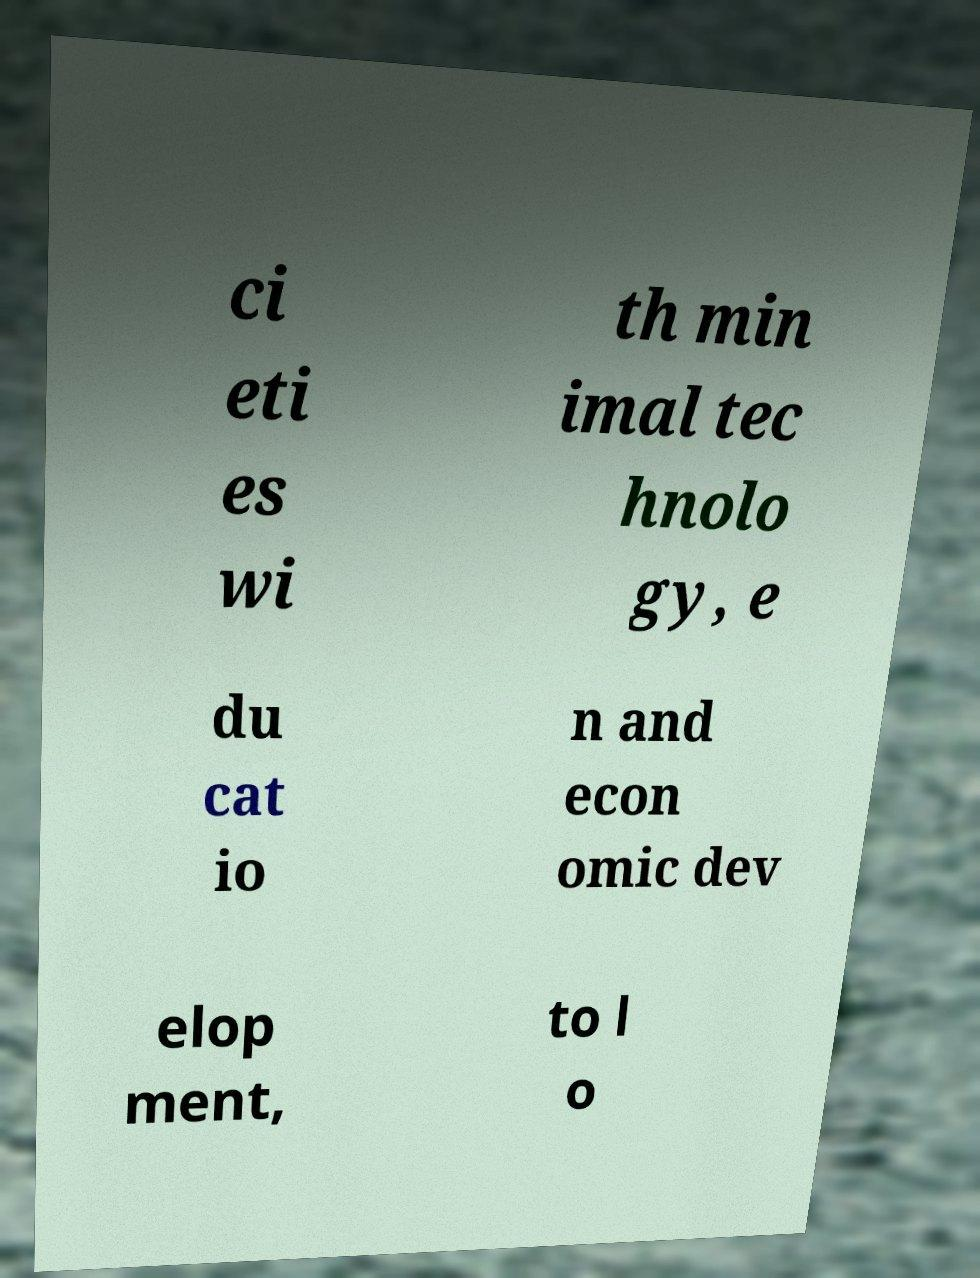Can you read and provide the text displayed in the image?This photo seems to have some interesting text. Can you extract and type it out for me? ci eti es wi th min imal tec hnolo gy, e du cat io n and econ omic dev elop ment, to l o 